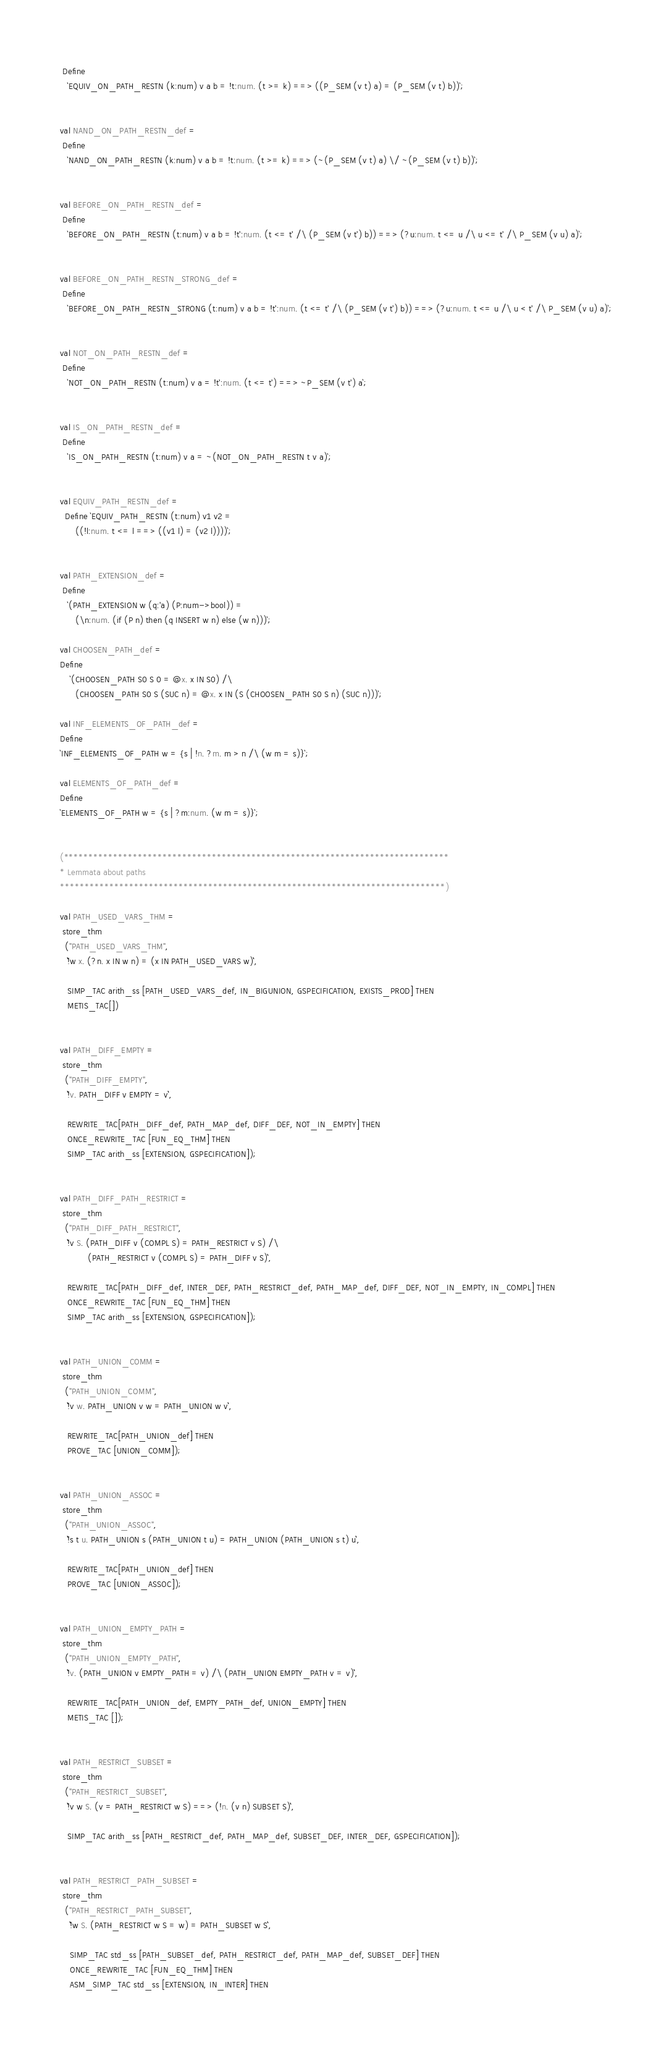Convert code to text. <code><loc_0><loc_0><loc_500><loc_500><_SML_> Define
   `EQUIV_ON_PATH_RESTN (k:num) v a b = !t:num. (t >= k) ==> ((P_SEM (v t) a) = (P_SEM (v t) b))`;


val NAND_ON_PATH_RESTN_def =
 Define
   `NAND_ON_PATH_RESTN (k:num) v a b = !t:num. (t >= k) ==> (~(P_SEM (v t) a) \/ ~(P_SEM (v t) b))`;


val BEFORE_ON_PATH_RESTN_def =
 Define
   `BEFORE_ON_PATH_RESTN (t:num) v a b = !t':num. (t <= t' /\ (P_SEM (v t') b)) ==> (?u:num. t <= u /\ u <= t' /\ P_SEM (v u) a)`;


val BEFORE_ON_PATH_RESTN_STRONG_def =
 Define
   `BEFORE_ON_PATH_RESTN_STRONG (t:num) v a b = !t':num. (t <= t' /\ (P_SEM (v t') b)) ==> (?u:num. t <= u /\ u < t' /\ P_SEM (v u) a)`;


val NOT_ON_PATH_RESTN_def =
 Define
   `NOT_ON_PATH_RESTN (t:num) v a = !t':num. (t <= t') ==> ~P_SEM (v t') a`;


val IS_ON_PATH_RESTN_def =
 Define
   `IS_ON_PATH_RESTN (t:num) v a = ~(NOT_ON_PATH_RESTN t v a)`;


val EQUIV_PATH_RESTN_def =
  Define `EQUIV_PATH_RESTN (t:num) v1 v2 =
      ((!l:num. t <= l ==> ((v1 l) = (v2 l))))`;


val PATH_EXTENSION_def =
 Define
   `(PATH_EXTENSION w (q:'a) (P:num->bool)) =
      (\n:num. (if (P n) then (q INSERT w n) else (w n)))`;

val CHOOSEN_PATH_def =
Define
    `(CHOOSEN_PATH S0 S 0 = @x. x IN S0) /\
      (CHOOSEN_PATH S0 S (SUC n) = @x. x IN (S (CHOOSEN_PATH S0 S n) (SUC n)))`;

val INF_ELEMENTS_OF_PATH_def =
Define
`INF_ELEMENTS_OF_PATH w = {s | !n. ?m. m > n /\ (w m = s)}`;

val ELEMENTS_OF_PATH_def =
Define
`ELEMENTS_OF_PATH w = {s | ?m:num. (w m = s)}`;


(******************************************************************************
* Lemmata about paths
******************************************************************************)

val PATH_USED_VARS_THM =
 store_thm
  ("PATH_USED_VARS_THM",
   ``!w x. (?n. x IN w n) = (x IN PATH_USED_VARS w)``,

   SIMP_TAC arith_ss [PATH_USED_VARS_def, IN_BIGUNION, GSPECIFICATION, EXISTS_PROD] THEN
   METIS_TAC[])


val PATH_DIFF_EMPTY =
 store_thm
  ("PATH_DIFF_EMPTY",
   ``!v. PATH_DIFF v EMPTY = v``,

   REWRITE_TAC[PATH_DIFF_def, PATH_MAP_def, DIFF_DEF, NOT_IN_EMPTY] THEN
   ONCE_REWRITE_TAC [FUN_EQ_THM] THEN
   SIMP_TAC arith_ss [EXTENSION, GSPECIFICATION]);


val PATH_DIFF_PATH_RESTRICT =
 store_thm
  ("PATH_DIFF_PATH_RESTRICT",
   ``!v S. (PATH_DIFF v (COMPL S) = PATH_RESTRICT v S) /\
           (PATH_RESTRICT v (COMPL S) = PATH_DIFF v S)``,

   REWRITE_TAC[PATH_DIFF_def, INTER_DEF, PATH_RESTRICT_def, PATH_MAP_def, DIFF_DEF, NOT_IN_EMPTY, IN_COMPL] THEN
   ONCE_REWRITE_TAC [FUN_EQ_THM] THEN
   SIMP_TAC arith_ss [EXTENSION, GSPECIFICATION]);


val PATH_UNION_COMM =
 store_thm
  ("PATH_UNION_COMM",
   ``!v w. PATH_UNION v w = PATH_UNION w v``,

   REWRITE_TAC[PATH_UNION_def] THEN
   PROVE_TAC [UNION_COMM]);


val PATH_UNION_ASSOC =
 store_thm
  ("PATH_UNION_ASSOC",
   ``!s t u. PATH_UNION s (PATH_UNION t u) = PATH_UNION (PATH_UNION s t) u``,

   REWRITE_TAC[PATH_UNION_def] THEN
   PROVE_TAC [UNION_ASSOC]);


val PATH_UNION_EMPTY_PATH =
 store_thm
  ("PATH_UNION_EMPTY_PATH",
   ``!v. (PATH_UNION v EMPTY_PATH = v) /\ (PATH_UNION EMPTY_PATH v = v)``,

   REWRITE_TAC[PATH_UNION_def, EMPTY_PATH_def, UNION_EMPTY] THEN
   METIS_TAC []);


val PATH_RESTRICT_SUBSET =
 store_thm
  ("PATH_RESTRICT_SUBSET",
   ``!v w S. (v = PATH_RESTRICT w S) ==> (!n. (v n) SUBSET S)``,

   SIMP_TAC arith_ss [PATH_RESTRICT_def, PATH_MAP_def, SUBSET_DEF, INTER_DEF, GSPECIFICATION]);


val PATH_RESTRICT_PATH_SUBSET =
 store_thm
  ("PATH_RESTRICT_PATH_SUBSET",
    ``!w S. (PATH_RESTRICT w S = w) = PATH_SUBSET w S``,

    SIMP_TAC std_ss [PATH_SUBSET_def, PATH_RESTRICT_def, PATH_MAP_def, SUBSET_DEF] THEN
    ONCE_REWRITE_TAC [FUN_EQ_THM] THEN
    ASM_SIMP_TAC std_ss [EXTENSION, IN_INTER] THEN</code> 